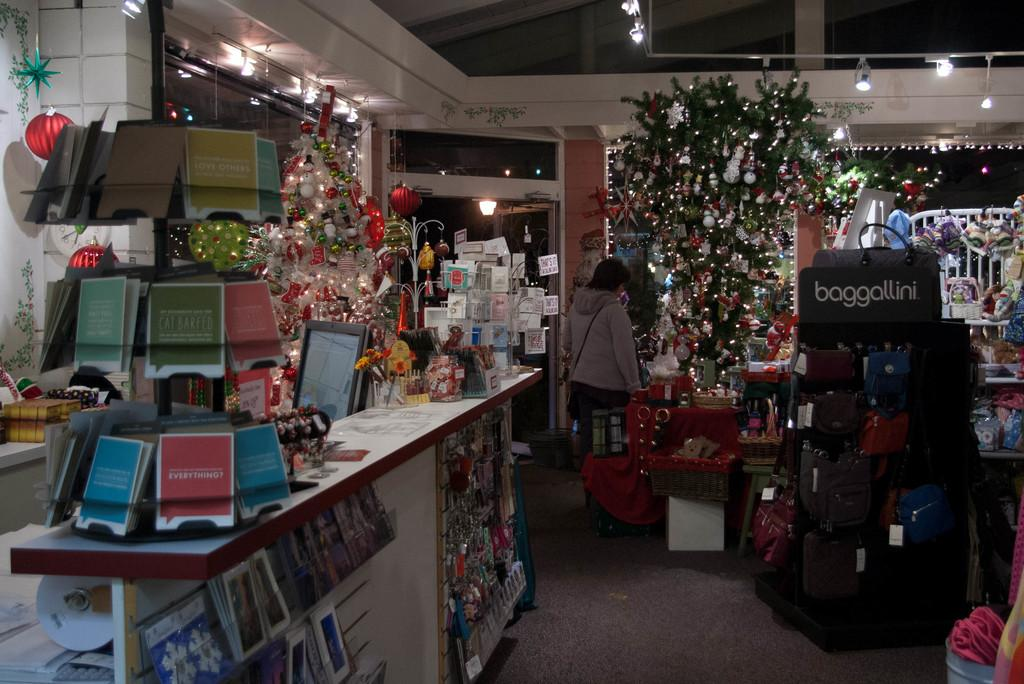Provide a one-sentence caption for the provided image. A store that carries the brand "baggallini" is decorated for Christmas. 